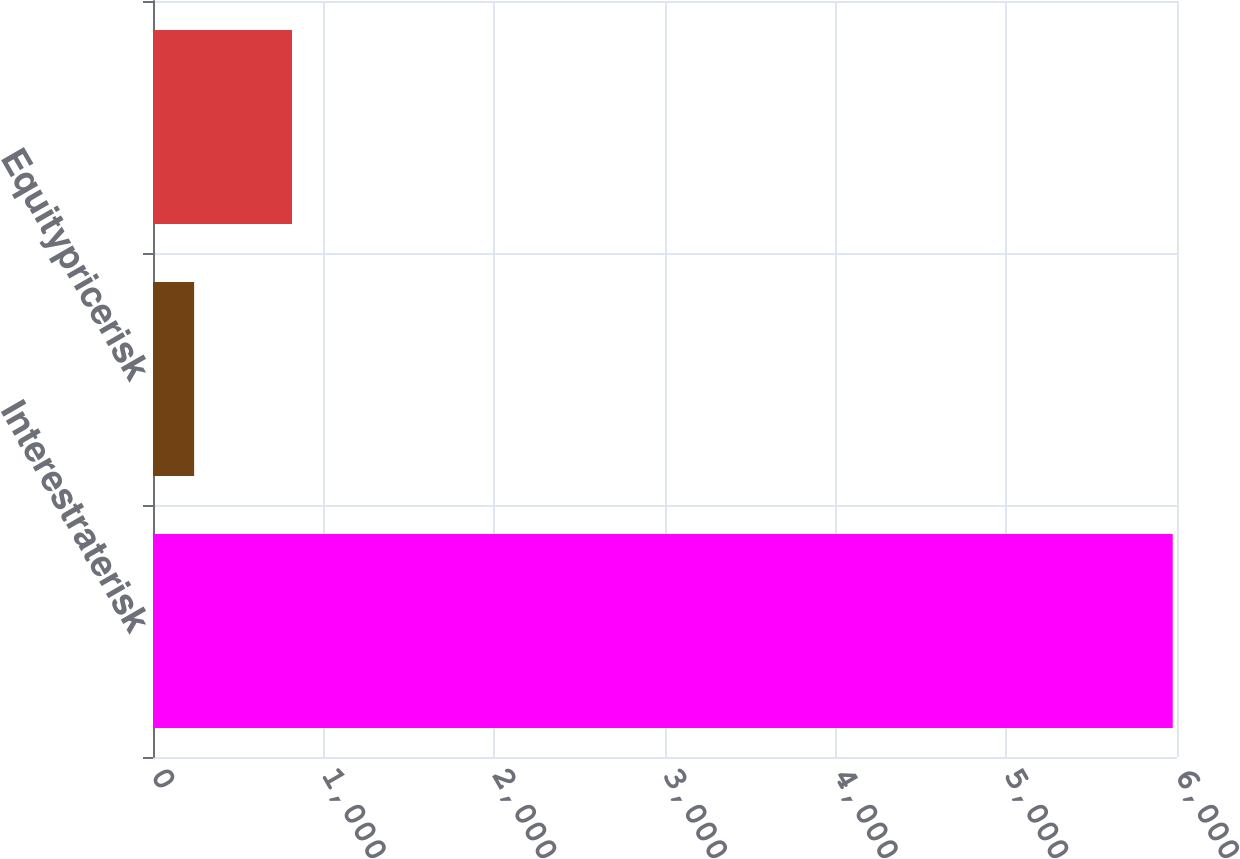<chart> <loc_0><loc_0><loc_500><loc_500><bar_chart><fcel>Interestraterisk<fcel>Equitypricerisk<fcel>Unnamed: 2<nl><fcel>5975<fcel>241<fcel>814.4<nl></chart> 